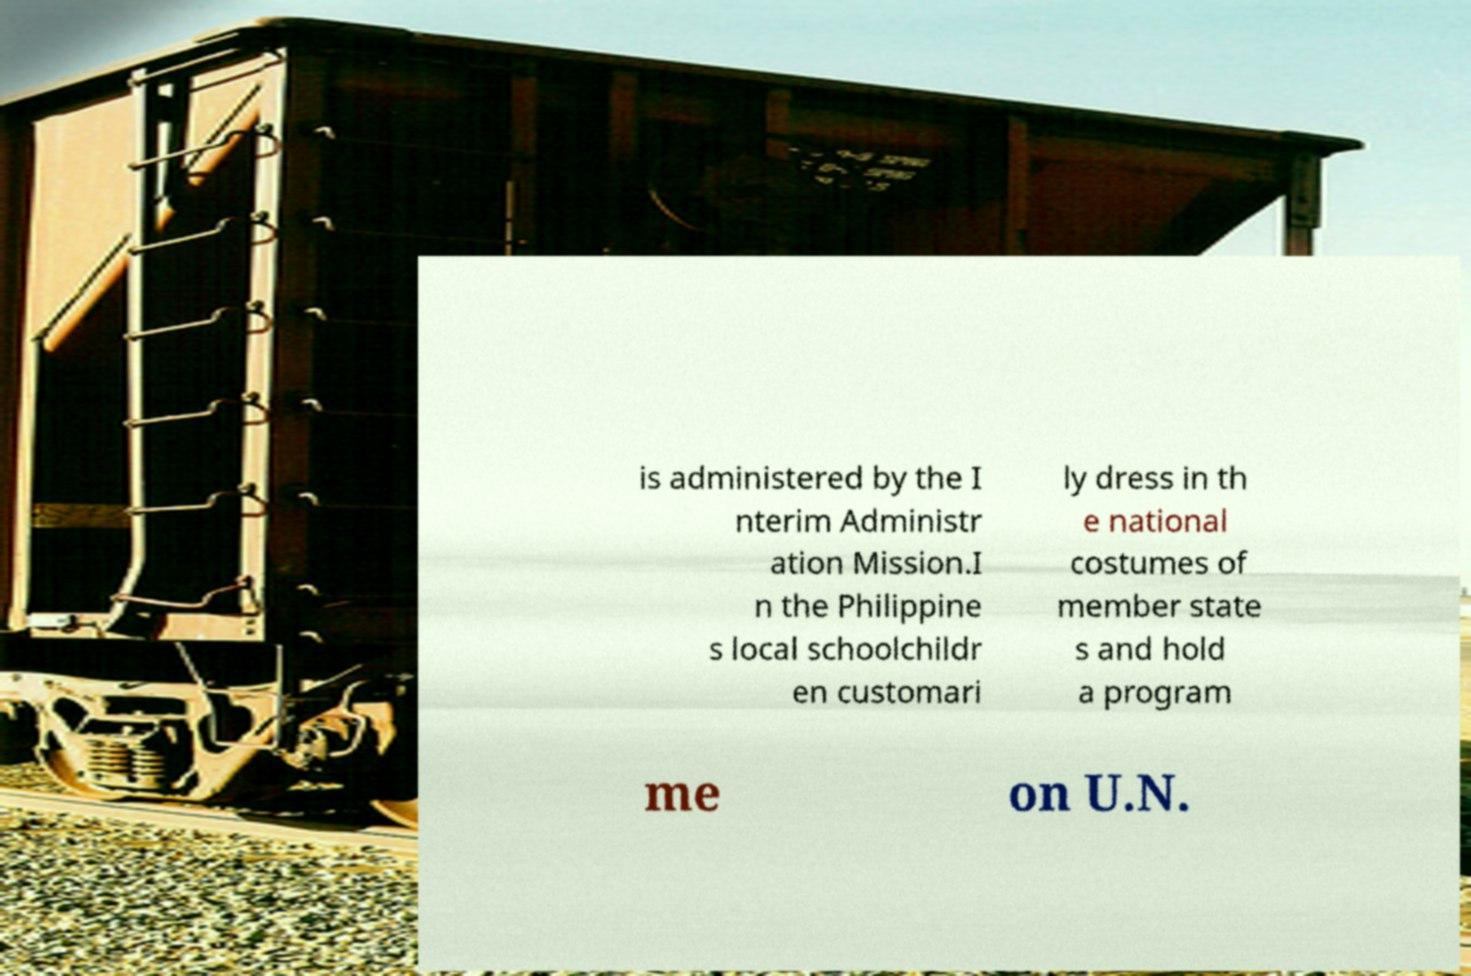Can you read and provide the text displayed in the image?This photo seems to have some interesting text. Can you extract and type it out for me? is administered by the I nterim Administr ation Mission.I n the Philippine s local schoolchildr en customari ly dress in th e national costumes of member state s and hold a program me on U.N. 